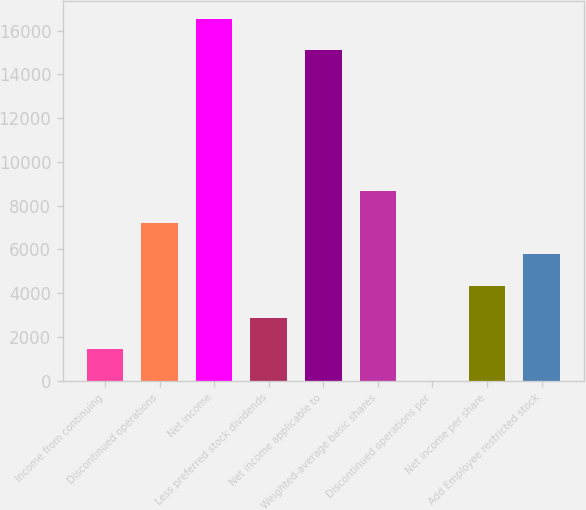<chart> <loc_0><loc_0><loc_500><loc_500><bar_chart><fcel>Income from continuing<fcel>Discontinued operations<fcel>Net income<fcel>Less preferred stock dividends<fcel>Net income applicable to<fcel>Weighted-average basic shares<fcel>Discontinued operations per<fcel>Net income per share<fcel>Add Employee restricted stock<nl><fcel>1444.61<fcel>7222.13<fcel>16537.8<fcel>2888.99<fcel>15093.4<fcel>8666.51<fcel>0.23<fcel>4333.37<fcel>5777.75<nl></chart> 